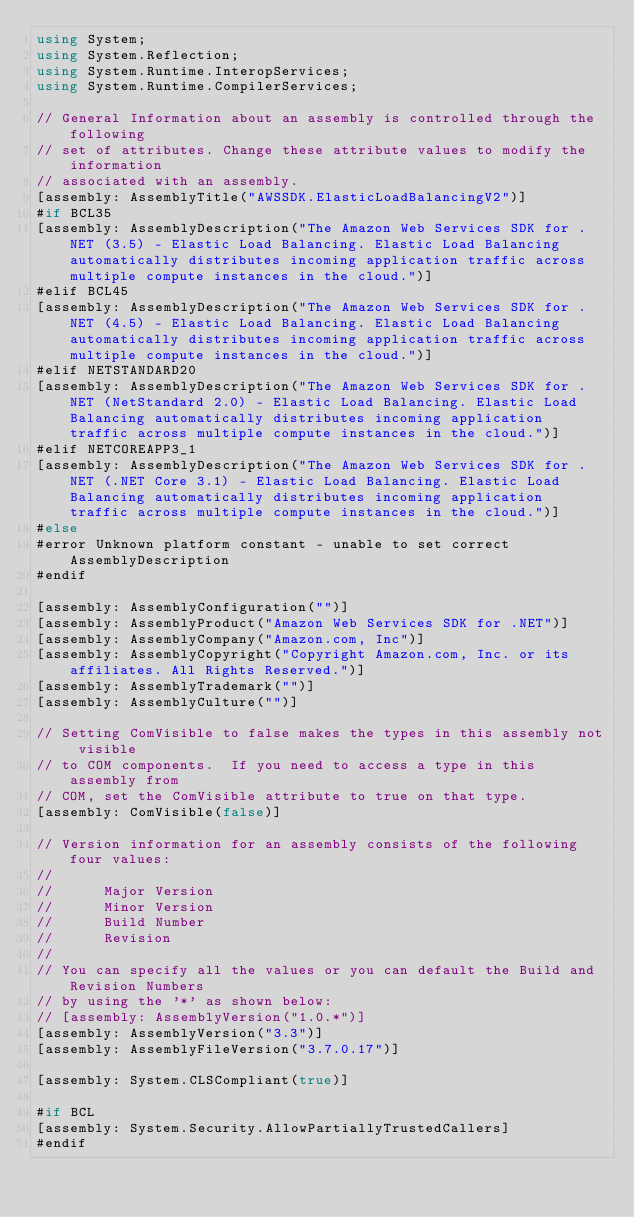<code> <loc_0><loc_0><loc_500><loc_500><_C#_>using System;
using System.Reflection;
using System.Runtime.InteropServices;
using System.Runtime.CompilerServices;

// General Information about an assembly is controlled through the following 
// set of attributes. Change these attribute values to modify the information
// associated with an assembly.
[assembly: AssemblyTitle("AWSSDK.ElasticLoadBalancingV2")]
#if BCL35
[assembly: AssemblyDescription("The Amazon Web Services SDK for .NET (3.5) - Elastic Load Balancing. Elastic Load Balancing automatically distributes incoming application traffic across multiple compute instances in the cloud.")]
#elif BCL45
[assembly: AssemblyDescription("The Amazon Web Services SDK for .NET (4.5) - Elastic Load Balancing. Elastic Load Balancing automatically distributes incoming application traffic across multiple compute instances in the cloud.")]
#elif NETSTANDARD20
[assembly: AssemblyDescription("The Amazon Web Services SDK for .NET (NetStandard 2.0) - Elastic Load Balancing. Elastic Load Balancing automatically distributes incoming application traffic across multiple compute instances in the cloud.")]
#elif NETCOREAPP3_1
[assembly: AssemblyDescription("The Amazon Web Services SDK for .NET (.NET Core 3.1) - Elastic Load Balancing. Elastic Load Balancing automatically distributes incoming application traffic across multiple compute instances in the cloud.")]
#else
#error Unknown platform constant - unable to set correct AssemblyDescription
#endif

[assembly: AssemblyConfiguration("")]
[assembly: AssemblyProduct("Amazon Web Services SDK for .NET")]
[assembly: AssemblyCompany("Amazon.com, Inc")]
[assembly: AssemblyCopyright("Copyright Amazon.com, Inc. or its affiliates. All Rights Reserved.")]
[assembly: AssemblyTrademark("")]
[assembly: AssemblyCulture("")]

// Setting ComVisible to false makes the types in this assembly not visible 
// to COM components.  If you need to access a type in this assembly from 
// COM, set the ComVisible attribute to true on that type.
[assembly: ComVisible(false)]

// Version information for an assembly consists of the following four values:
//
//      Major Version
//      Minor Version 
//      Build Number
//      Revision
//
// You can specify all the values or you can default the Build and Revision Numbers 
// by using the '*' as shown below:
// [assembly: AssemblyVersion("1.0.*")]
[assembly: AssemblyVersion("3.3")]
[assembly: AssemblyFileVersion("3.7.0.17")]

[assembly: System.CLSCompliant(true)]

#if BCL
[assembly: System.Security.AllowPartiallyTrustedCallers]
#endif</code> 